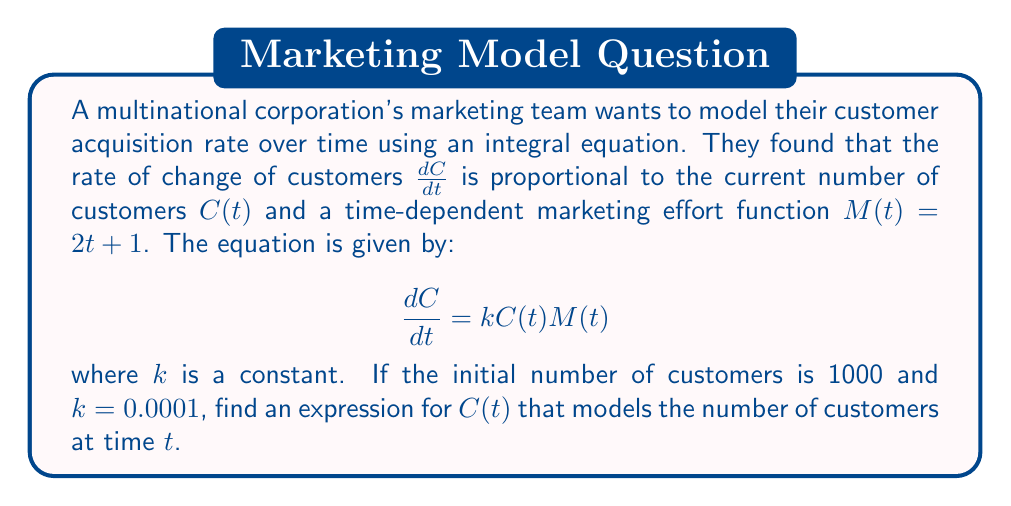Can you solve this math problem? To solve this integral equation, we'll follow these steps:

1) First, separate variables and integrate both sides:
   $$\int \frac{dC}{C} = k \int (2t + 1) dt$$

2) Evaluate the integrals:
   $$\ln|C| = k(t^2 + t) + A$$
   where $A$ is the constant of integration.

3) Exponentiate both sides:
   $$C = e^{k(t^2 + t) + A} = Be^{k(t^2 + t)}$$
   where $B = e^A$ is a new constant.

4) Use the initial condition to find $B$:
   At $t = 0$, $C(0) = 1000$
   $$1000 = Be^{k(0^2 + 0)} = B$$

5) Therefore, the final expression for $C(t)$ is:
   $$C(t) = 1000e^{0.0001(t^2 + t)}$$

This expression models the number of customers at time $t$, considering the initial customer base and the time-dependent marketing efforts.
Answer: $C(t) = 1000e^{0.0001(t^2 + t)}$ 